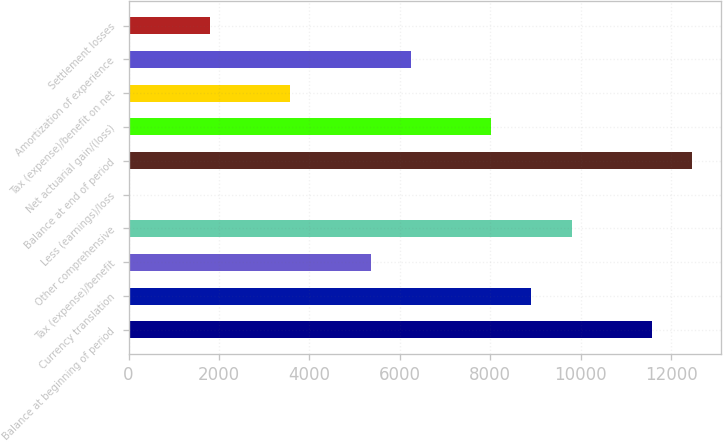Convert chart. <chart><loc_0><loc_0><loc_500><loc_500><bar_chart><fcel>Balance at beginning of period<fcel>Currency translation<fcel>Tax (expense)/benefit<fcel>Other comprehensive<fcel>Less (earnings)/loss<fcel>Balance at end of period<fcel>Net actuarial gain/(loss)<fcel>Tax (expense)/benefit on net<fcel>Amortization of experience<fcel>Settlement losses<nl><fcel>11577.9<fcel>8910<fcel>5352.8<fcel>9799.3<fcel>17<fcel>12467.2<fcel>8020.7<fcel>3574.2<fcel>6242.1<fcel>1795.6<nl></chart> 